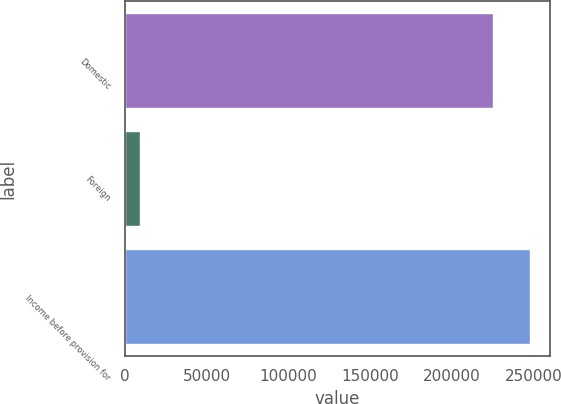<chart> <loc_0><loc_0><loc_500><loc_500><bar_chart><fcel>Domestic<fcel>Foreign<fcel>Income before provision for<nl><fcel>225079<fcel>9456<fcel>247587<nl></chart> 